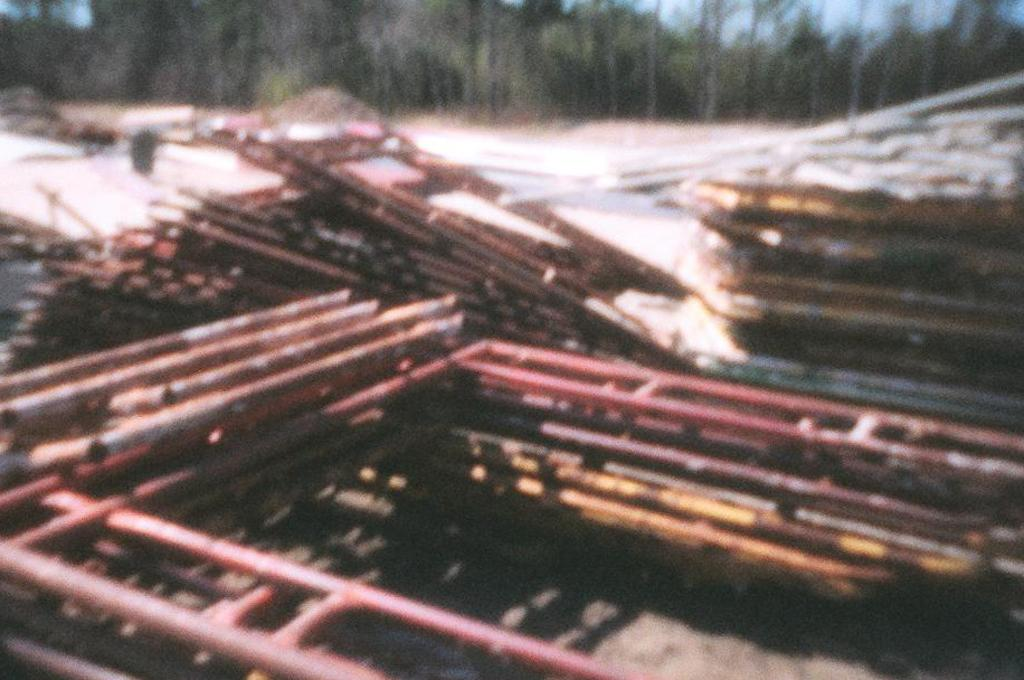What type of objects are present in the image? There are metal rods in the image. Can you describe the quality of the image's background? The image is blurry in the background. How does the basketball help the person in the image? There is no basketball present in the image, so it cannot help anyone in the image. 